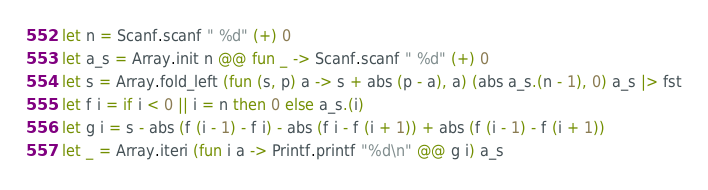<code> <loc_0><loc_0><loc_500><loc_500><_OCaml_>let n = Scanf.scanf " %d" (+) 0
let a_s = Array.init n @@ fun _ -> Scanf.scanf " %d" (+) 0
let s = Array.fold_left (fun (s, p) a -> s + abs (p - a), a) (abs a_s.(n - 1), 0) a_s |> fst
let f i = if i < 0 || i = n then 0 else a_s.(i)
let g i = s - abs (f (i - 1) - f i) - abs (f i - f (i + 1)) + abs (f (i - 1) - f (i + 1))
let _ = Array.iteri (fun i a -> Printf.printf "%d\n" @@ g i) a_s</code> 